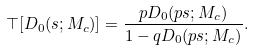Convert formula to latex. <formula><loc_0><loc_0><loc_500><loc_500>\top [ D _ { 0 } ( s ; M _ { c } ) ] = \frac { p D _ { 0 } ( p s ; M _ { c } ) } { 1 - q D _ { 0 } ( p s ; M _ { c } ) } .</formula> 